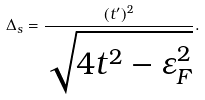<formula> <loc_0><loc_0><loc_500><loc_500>\Delta _ { s } = \frac { ( t ^ { \prime } ) ^ { 2 } } { \sqrt { 4 t ^ { 2 } - \varepsilon _ { F } ^ { 2 } } } .</formula> 